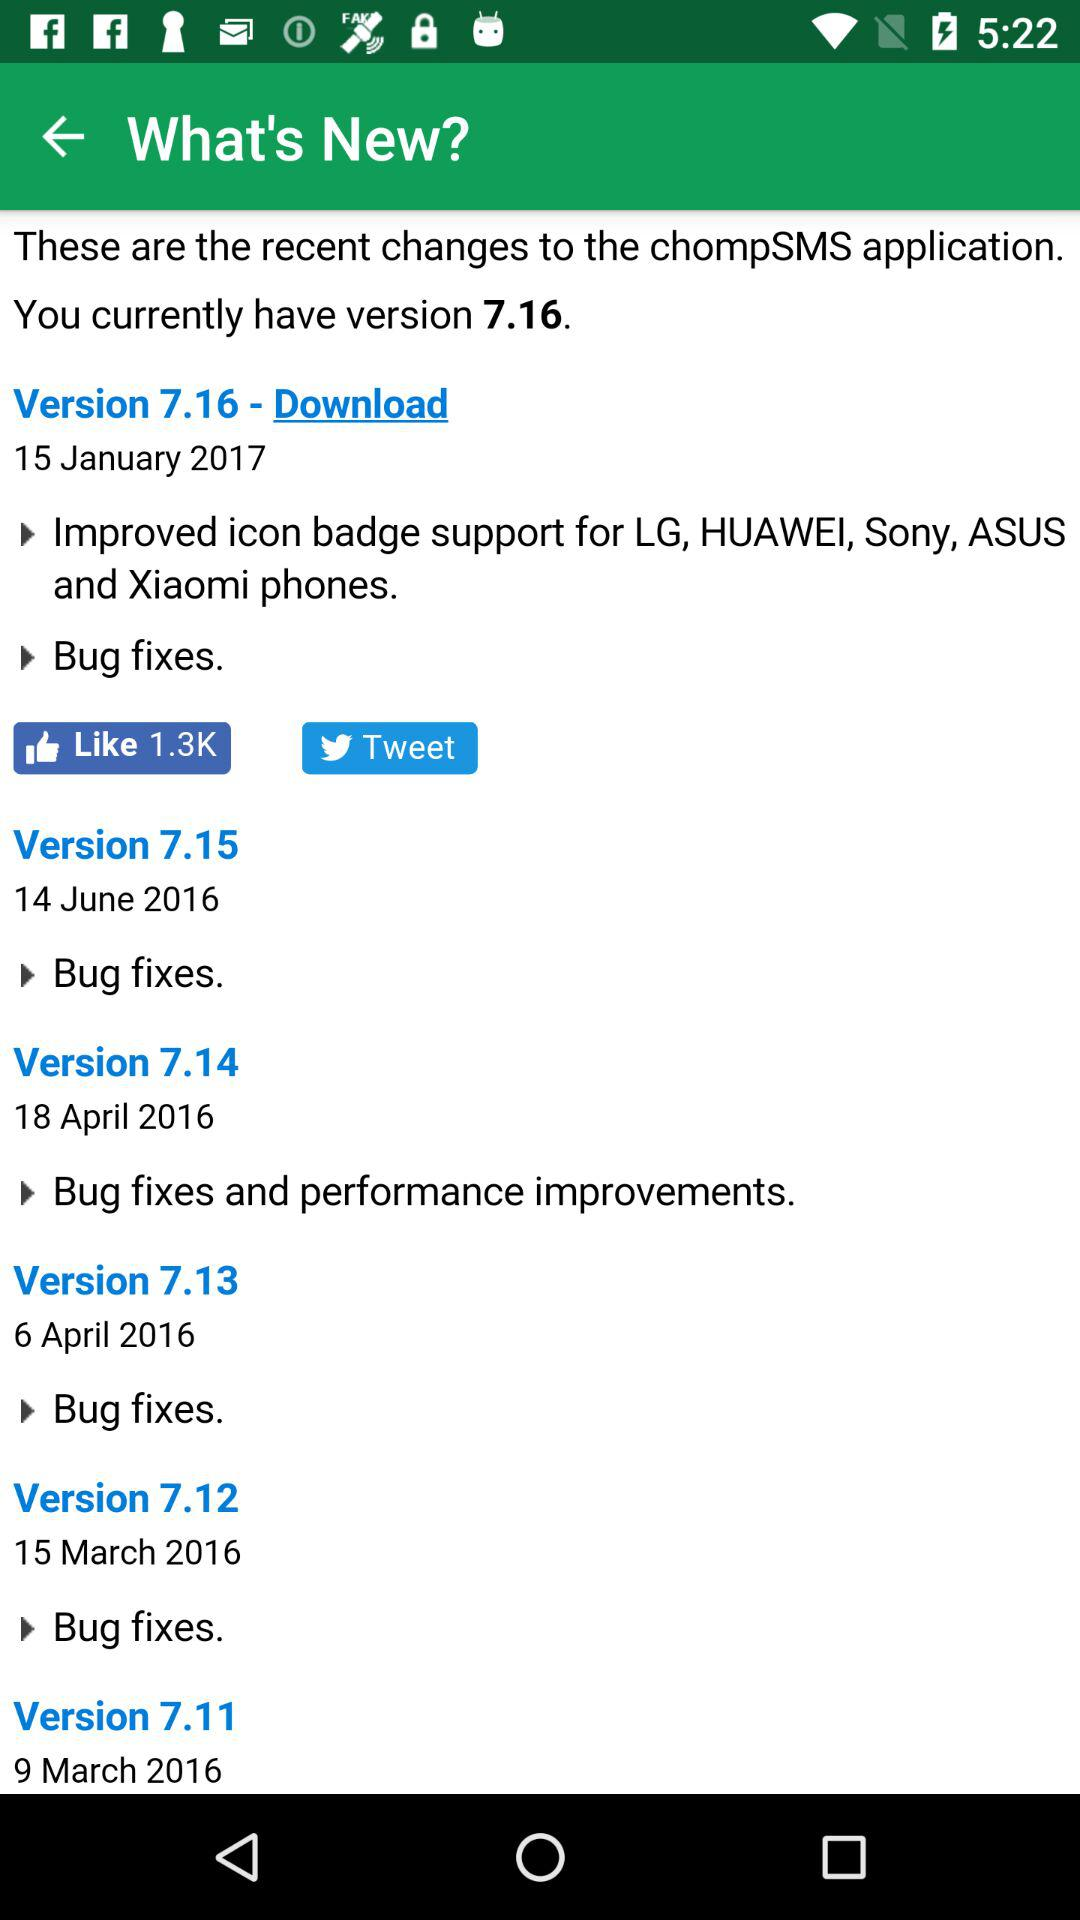Which is the version released on April 6, 2016? The version is 7.13. 